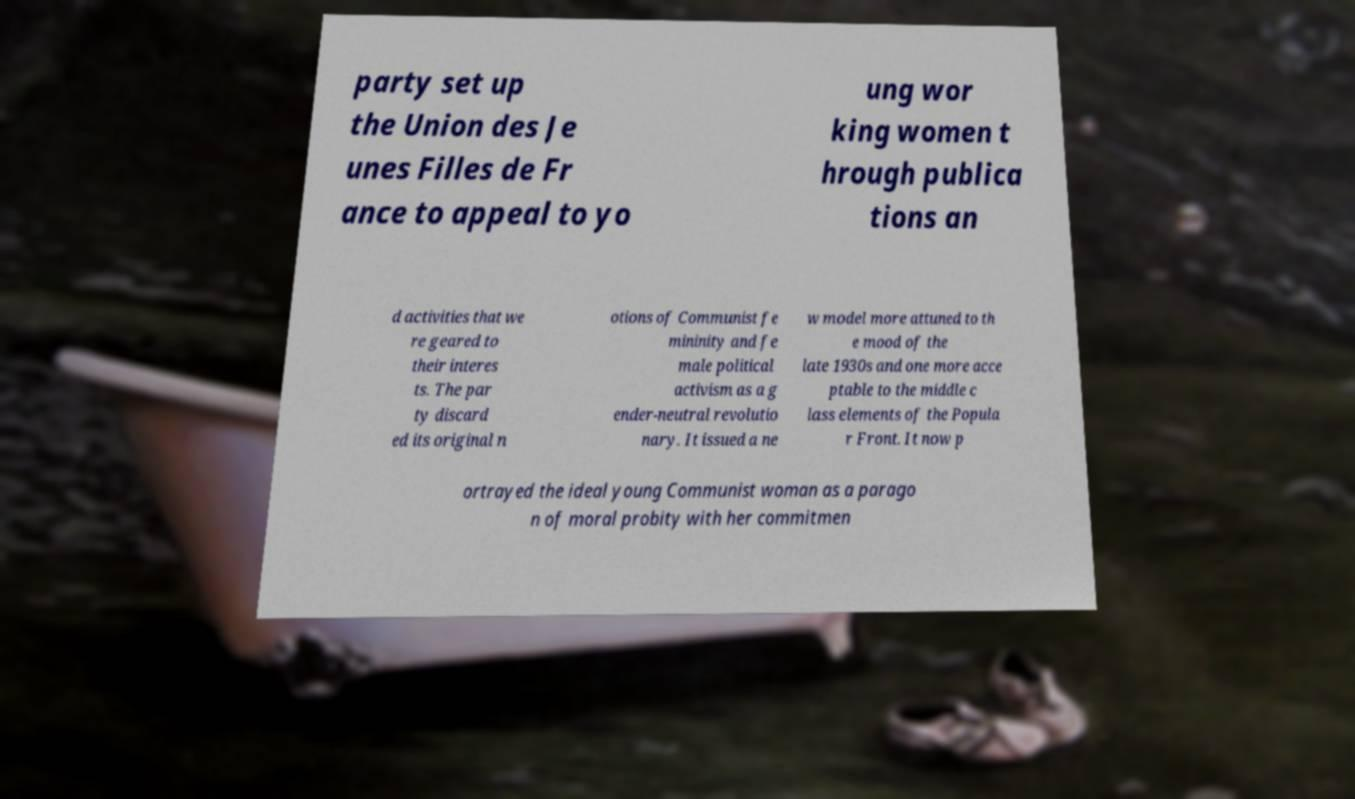For documentation purposes, I need the text within this image transcribed. Could you provide that? party set up the Union des Je unes Filles de Fr ance to appeal to yo ung wor king women t hrough publica tions an d activities that we re geared to their interes ts. The par ty discard ed its original n otions of Communist fe mininity and fe male political activism as a g ender-neutral revolutio nary. It issued a ne w model more attuned to th e mood of the late 1930s and one more acce ptable to the middle c lass elements of the Popula r Front. It now p ortrayed the ideal young Communist woman as a parago n of moral probity with her commitmen 